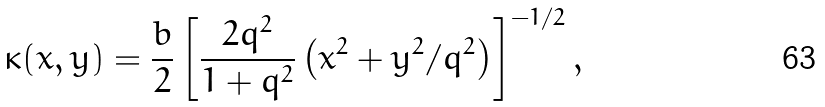<formula> <loc_0><loc_0><loc_500><loc_500>\kappa ( x , y ) = \frac { b } { 2 } \left [ \frac { 2 q ^ { 2 } } { 1 + q ^ { 2 } } \left ( x ^ { 2 } + y ^ { 2 } / q ^ { 2 } \right ) \right ] ^ { - 1 / 2 } ,</formula> 